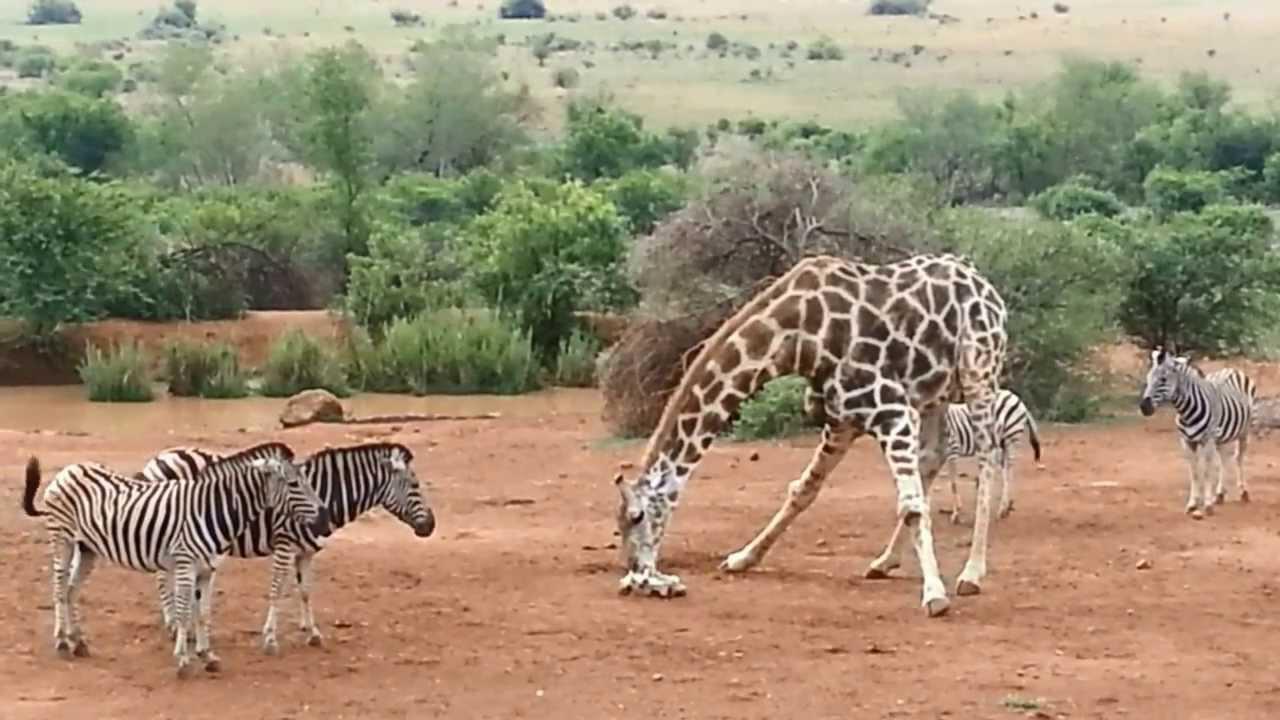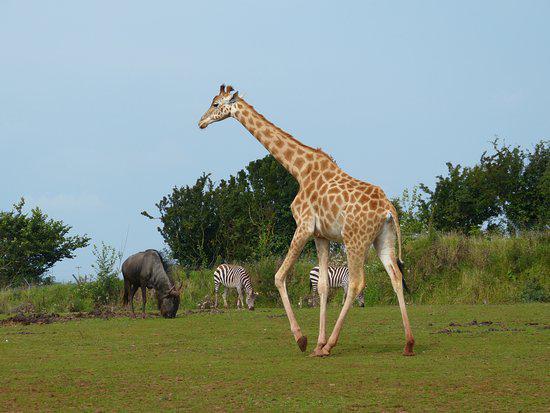The first image is the image on the left, the second image is the image on the right. For the images displayed, is the sentence "Multiple zebras and gnus, including multiple rear-facing animals, are at a watering hole in one image." factually correct? Answer yes or no. No. The first image is the image on the left, the second image is the image on the right. Analyze the images presented: Is the assertion "In one image, only zebras and no other species can be seen." valid? Answer yes or no. No. 